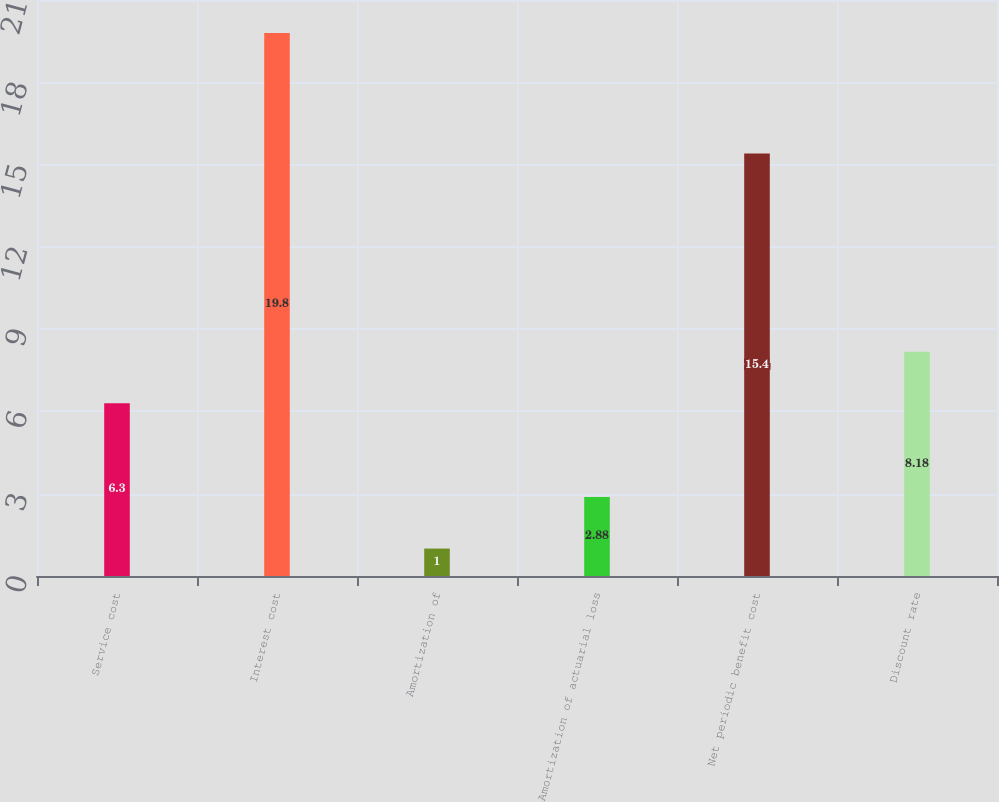<chart> <loc_0><loc_0><loc_500><loc_500><bar_chart><fcel>Service cost<fcel>Interest cost<fcel>Amortization of<fcel>Amortization of actuarial loss<fcel>Net periodic benefit cost<fcel>Discount rate<nl><fcel>6.3<fcel>19.8<fcel>1<fcel>2.88<fcel>15.4<fcel>8.18<nl></chart> 